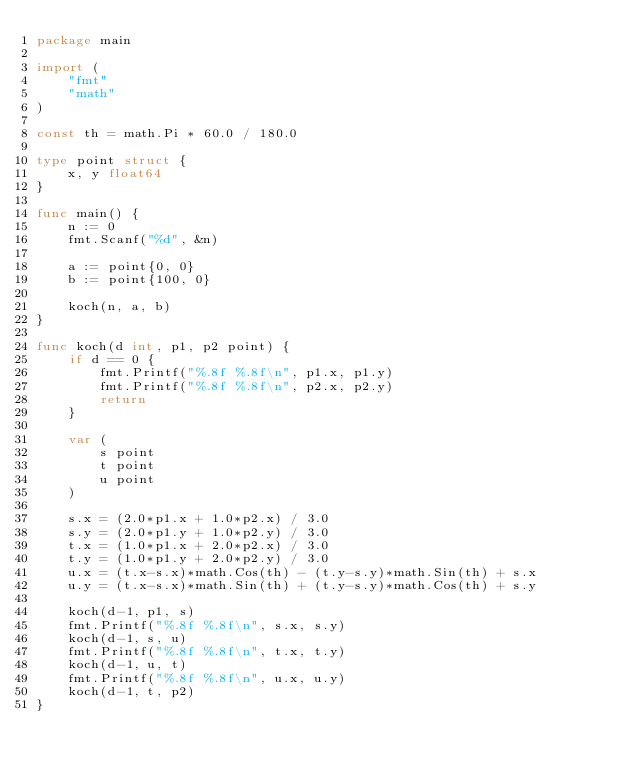<code> <loc_0><loc_0><loc_500><loc_500><_Go_>package main

import (
	"fmt"
	"math"
)

const th = math.Pi * 60.0 / 180.0

type point struct {
	x, y float64
}

func main() {
	n := 0
	fmt.Scanf("%d", &n)

	a := point{0, 0}
	b := point{100, 0}

	koch(n, a, b)
}

func koch(d int, p1, p2 point) {
	if d == 0 {
		fmt.Printf("%.8f %.8f\n", p1.x, p1.y)
		fmt.Printf("%.8f %.8f\n", p2.x, p2.y)
		return
	}

	var (
		s point
		t point
		u point
	)

	s.x = (2.0*p1.x + 1.0*p2.x) / 3.0
	s.y = (2.0*p1.y + 1.0*p2.y) / 3.0
	t.x = (1.0*p1.x + 2.0*p2.x) / 3.0
	t.y = (1.0*p1.y + 2.0*p2.y) / 3.0
	u.x = (t.x-s.x)*math.Cos(th) - (t.y-s.y)*math.Sin(th) + s.x
	u.y = (t.x-s.x)*math.Sin(th) + (t.y-s.y)*math.Cos(th) + s.y

	koch(d-1, p1, s)
	fmt.Printf("%.8f %.8f\n", s.x, s.y)
	koch(d-1, s, u)
	fmt.Printf("%.8f %.8f\n", t.x, t.y)
	koch(d-1, u, t)
	fmt.Printf("%.8f %.8f\n", u.x, u.y)
	koch(d-1, t, p2)
}

</code> 